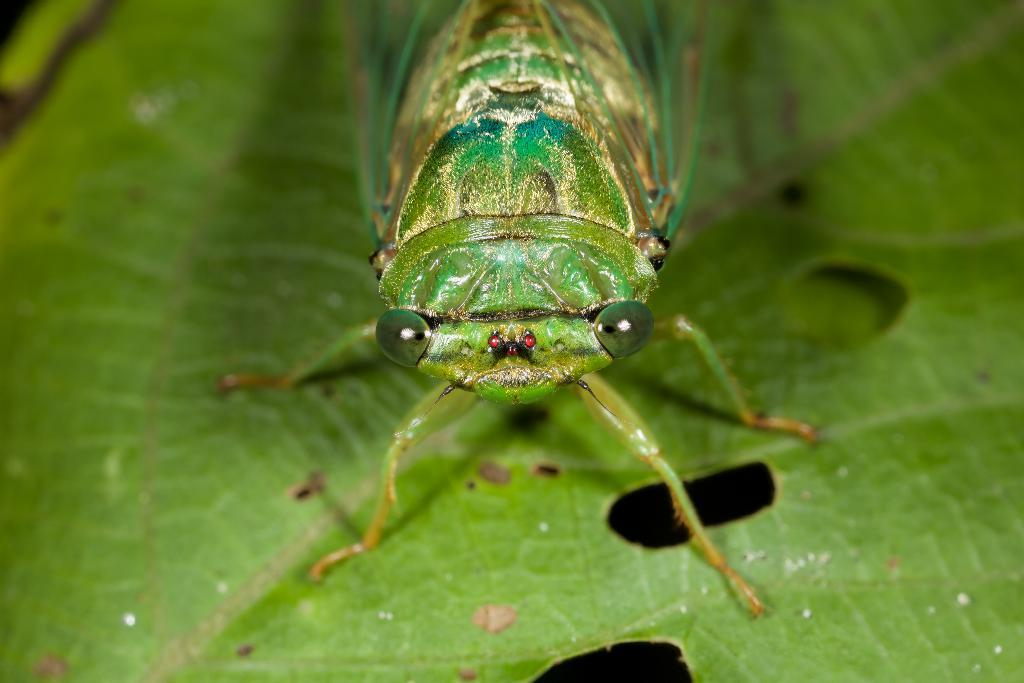What type of creature is present in the image? There is an insect in the image. Where is the insect located on the leaf? The insect is on a leaf. Can you describe the position of the insect in the image? The insect is located in the center of the image. What type of rice is being served in the image? There is no rice present in the image; it features an insect on a leaf. Can you tell me how much the receipt costs in the image? There is no receipt present in the image; it features an insect on a leaf. 